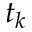Convert formula to latex. <formula><loc_0><loc_0><loc_500><loc_500>t _ { k }</formula> 